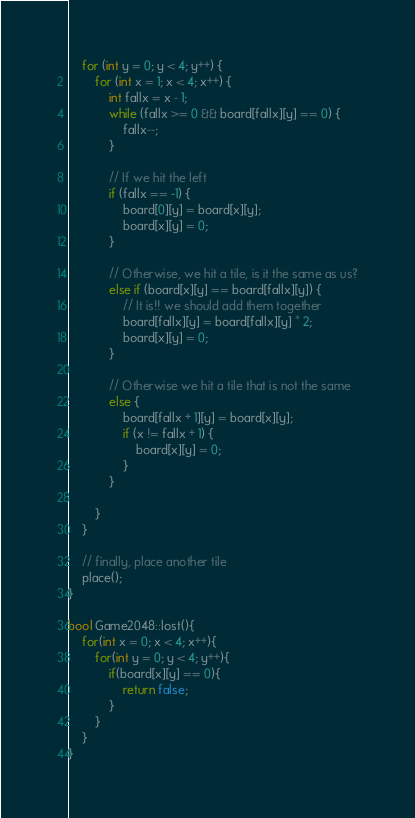<code> <loc_0><loc_0><loc_500><loc_500><_C++_>
	for (int y = 0; y < 4; y++) {
		for (int x = 1; x < 4; x++) {
			int fallx = x - 1;
			while (fallx >= 0 && board[fallx][y] == 0) {
				fallx--;
			}

			// If we hit the left 
			if (fallx == -1) {
				board[0][y] = board[x][y];
				board[x][y] = 0;
			}

			// Otherwise, we hit a tile, is it the same as us?
			else if (board[x][y] == board[fallx][y]) {
				// It is!! we should add them together
				board[fallx][y] = board[fallx][y] * 2;
				board[x][y] = 0;
			}

			// Otherwise we hit a tile that is not the same
			else {
				board[fallx + 1][y] = board[x][y];
				if (x != fallx + 1) {
					board[x][y] = 0;
				}
			}

		}
	}

	// finally, place another tile
	place();
}

bool Game2048::lost(){
	for(int x = 0; x < 4; x++){
		for(int y = 0; y < 4; y++){
			if(board[x][y] == 0){
				return false;
			}
		}
	}
}
</code> 